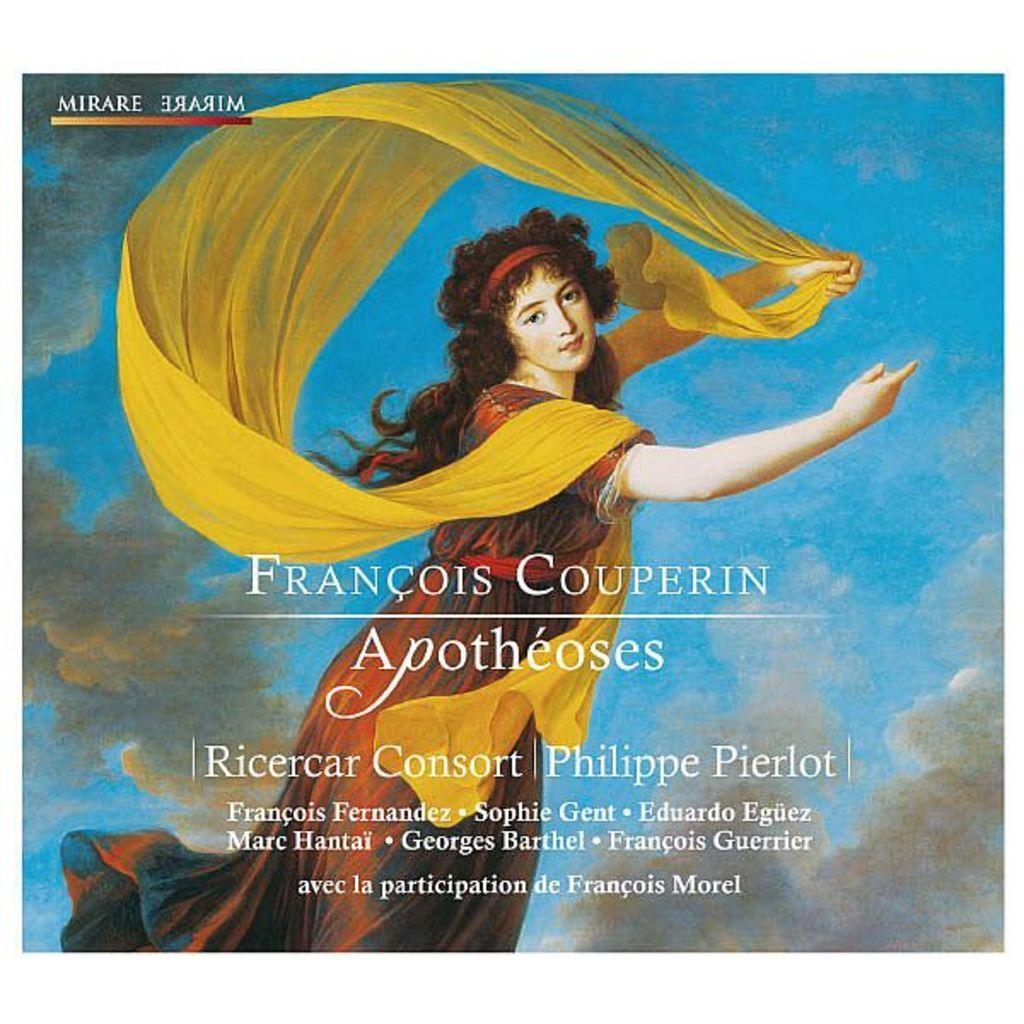<image>
Offer a succinct explanation of the picture presented. An album cover for Francois Couperin of a lady and a scarf 